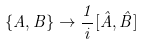Convert formula to latex. <formula><loc_0><loc_0><loc_500><loc_500>\{ A , B \} \rightarrow \frac { 1 } { i } [ \hat { A } , \hat { B } ]</formula> 